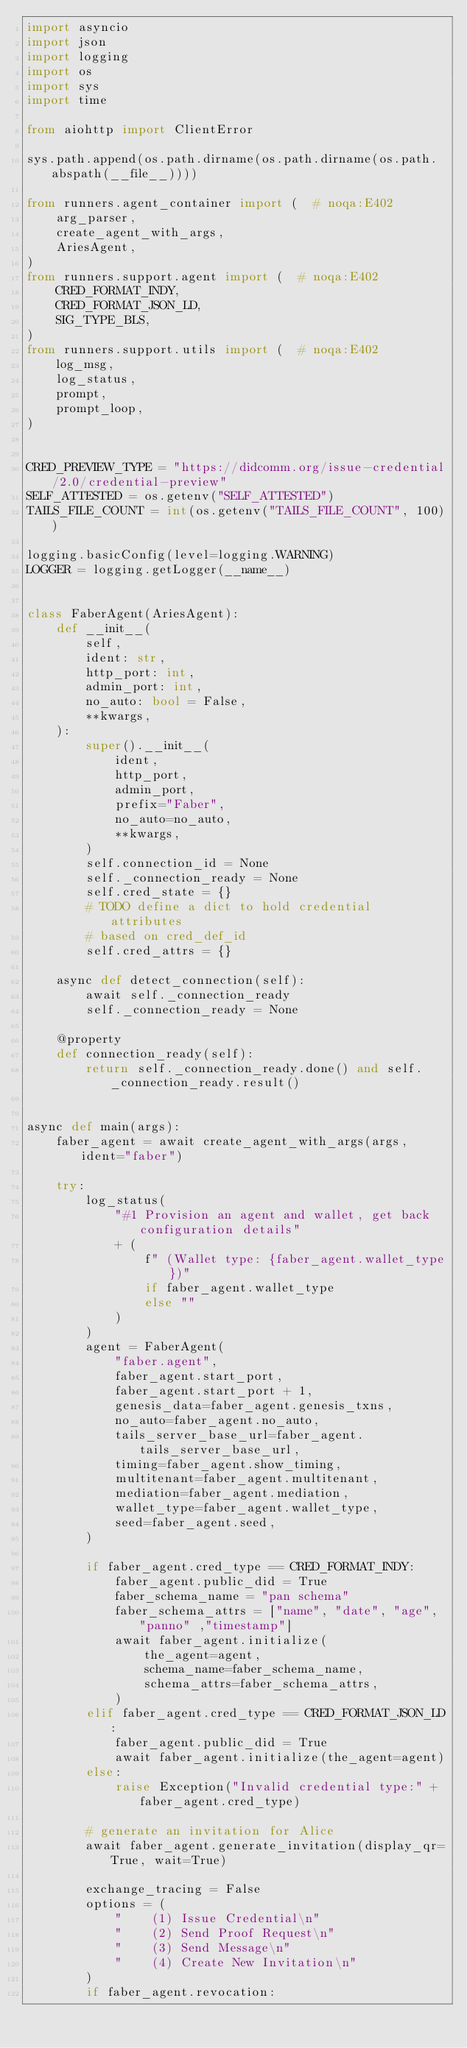Convert code to text. <code><loc_0><loc_0><loc_500><loc_500><_Python_>import asyncio
import json
import logging
import os
import sys
import time

from aiohttp import ClientError

sys.path.append(os.path.dirname(os.path.dirname(os.path.abspath(__file__))))

from runners.agent_container import (  # noqa:E402
    arg_parser,
    create_agent_with_args,
    AriesAgent,
)
from runners.support.agent import (  # noqa:E402
    CRED_FORMAT_INDY,
    CRED_FORMAT_JSON_LD,
    SIG_TYPE_BLS,
)
from runners.support.utils import (  # noqa:E402
    log_msg,
    log_status,
    prompt,
    prompt_loop,
)


CRED_PREVIEW_TYPE = "https://didcomm.org/issue-credential/2.0/credential-preview"
SELF_ATTESTED = os.getenv("SELF_ATTESTED")
TAILS_FILE_COUNT = int(os.getenv("TAILS_FILE_COUNT", 100))

logging.basicConfig(level=logging.WARNING)
LOGGER = logging.getLogger(__name__)


class FaberAgent(AriesAgent):
    def __init__(
        self,
        ident: str,
        http_port: int,
        admin_port: int,
        no_auto: bool = False,
        **kwargs,
    ):
        super().__init__(
            ident,
            http_port,
            admin_port,
            prefix="Faber",
            no_auto=no_auto,
            **kwargs,
        )
        self.connection_id = None
        self._connection_ready = None
        self.cred_state = {}
        # TODO define a dict to hold credential attributes
        # based on cred_def_id
        self.cred_attrs = {}

    async def detect_connection(self):
        await self._connection_ready
        self._connection_ready = None

    @property
    def connection_ready(self):
        return self._connection_ready.done() and self._connection_ready.result()


async def main(args):
    faber_agent = await create_agent_with_args(args, ident="faber")

    try:
        log_status(
            "#1 Provision an agent and wallet, get back configuration details"
            + (
                f" (Wallet type: {faber_agent.wallet_type})"
                if faber_agent.wallet_type
                else ""
            )
        )
        agent = FaberAgent(
            "faber.agent",
            faber_agent.start_port,
            faber_agent.start_port + 1,
            genesis_data=faber_agent.genesis_txns,
            no_auto=faber_agent.no_auto,
            tails_server_base_url=faber_agent.tails_server_base_url,
            timing=faber_agent.show_timing,
            multitenant=faber_agent.multitenant,
            mediation=faber_agent.mediation,
            wallet_type=faber_agent.wallet_type,
            seed=faber_agent.seed,
        )

        if faber_agent.cred_type == CRED_FORMAT_INDY:
            faber_agent.public_did = True
            faber_schema_name = "pan schema"
            faber_schema_attrs = ["name", "date", "age", "panno" ,"timestamp"]
            await faber_agent.initialize(
                the_agent=agent,
                schema_name=faber_schema_name,
                schema_attrs=faber_schema_attrs,
            )
        elif faber_agent.cred_type == CRED_FORMAT_JSON_LD:
            faber_agent.public_did = True
            await faber_agent.initialize(the_agent=agent)
        else:
            raise Exception("Invalid credential type:" + faber_agent.cred_type)

        # generate an invitation for Alice
        await faber_agent.generate_invitation(display_qr=True, wait=True)

        exchange_tracing = False
        options = (
            "    (1) Issue Credential\n"
            "    (2) Send Proof Request\n"
            "    (3) Send Message\n"
            "    (4) Create New Invitation\n"
        )
        if faber_agent.revocation:</code> 